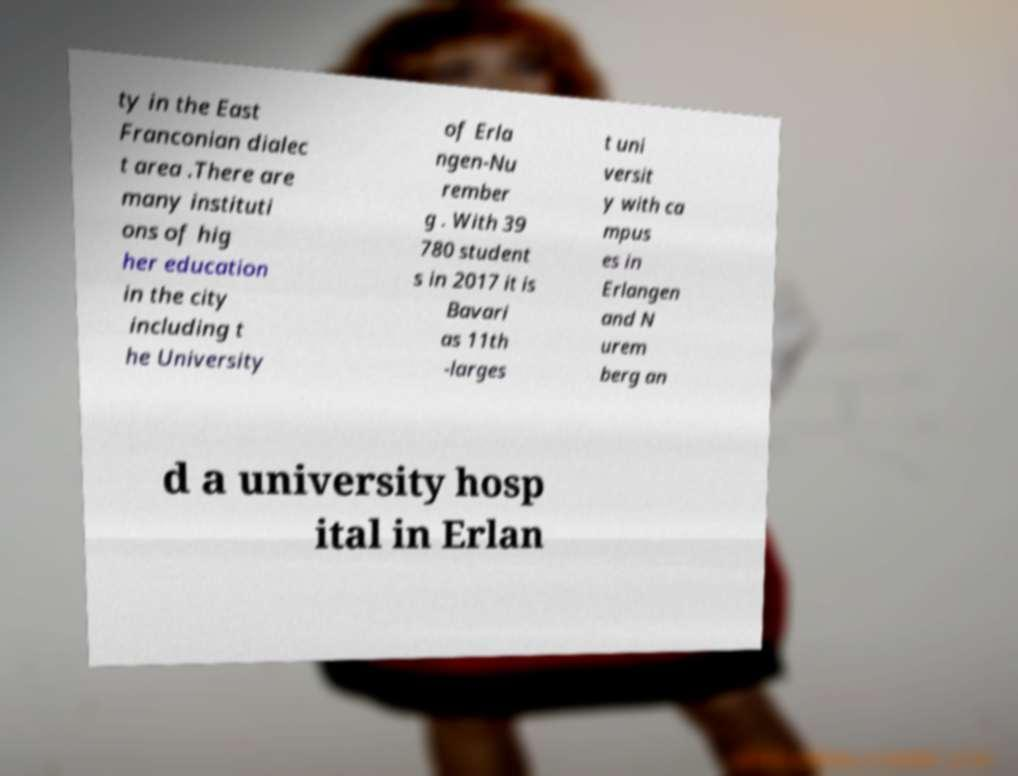I need the written content from this picture converted into text. Can you do that? ty in the East Franconian dialec t area .There are many instituti ons of hig her education in the city including t he University of Erla ngen-Nu rember g . With 39 780 student s in 2017 it is Bavari as 11th -larges t uni versit y with ca mpus es in Erlangen and N urem berg an d a university hosp ital in Erlan 